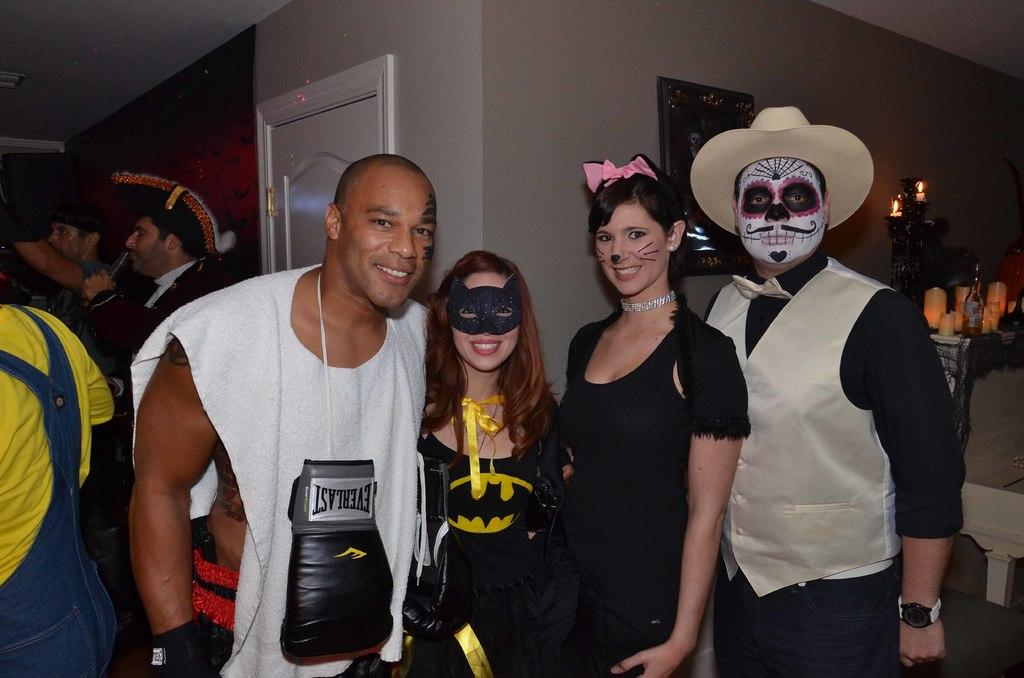<image>
Render a clear and concise summary of the photo. A man dressed up as Mike Tyson at a Halloween party has an Everlast boxing glove hanging around his neck. 